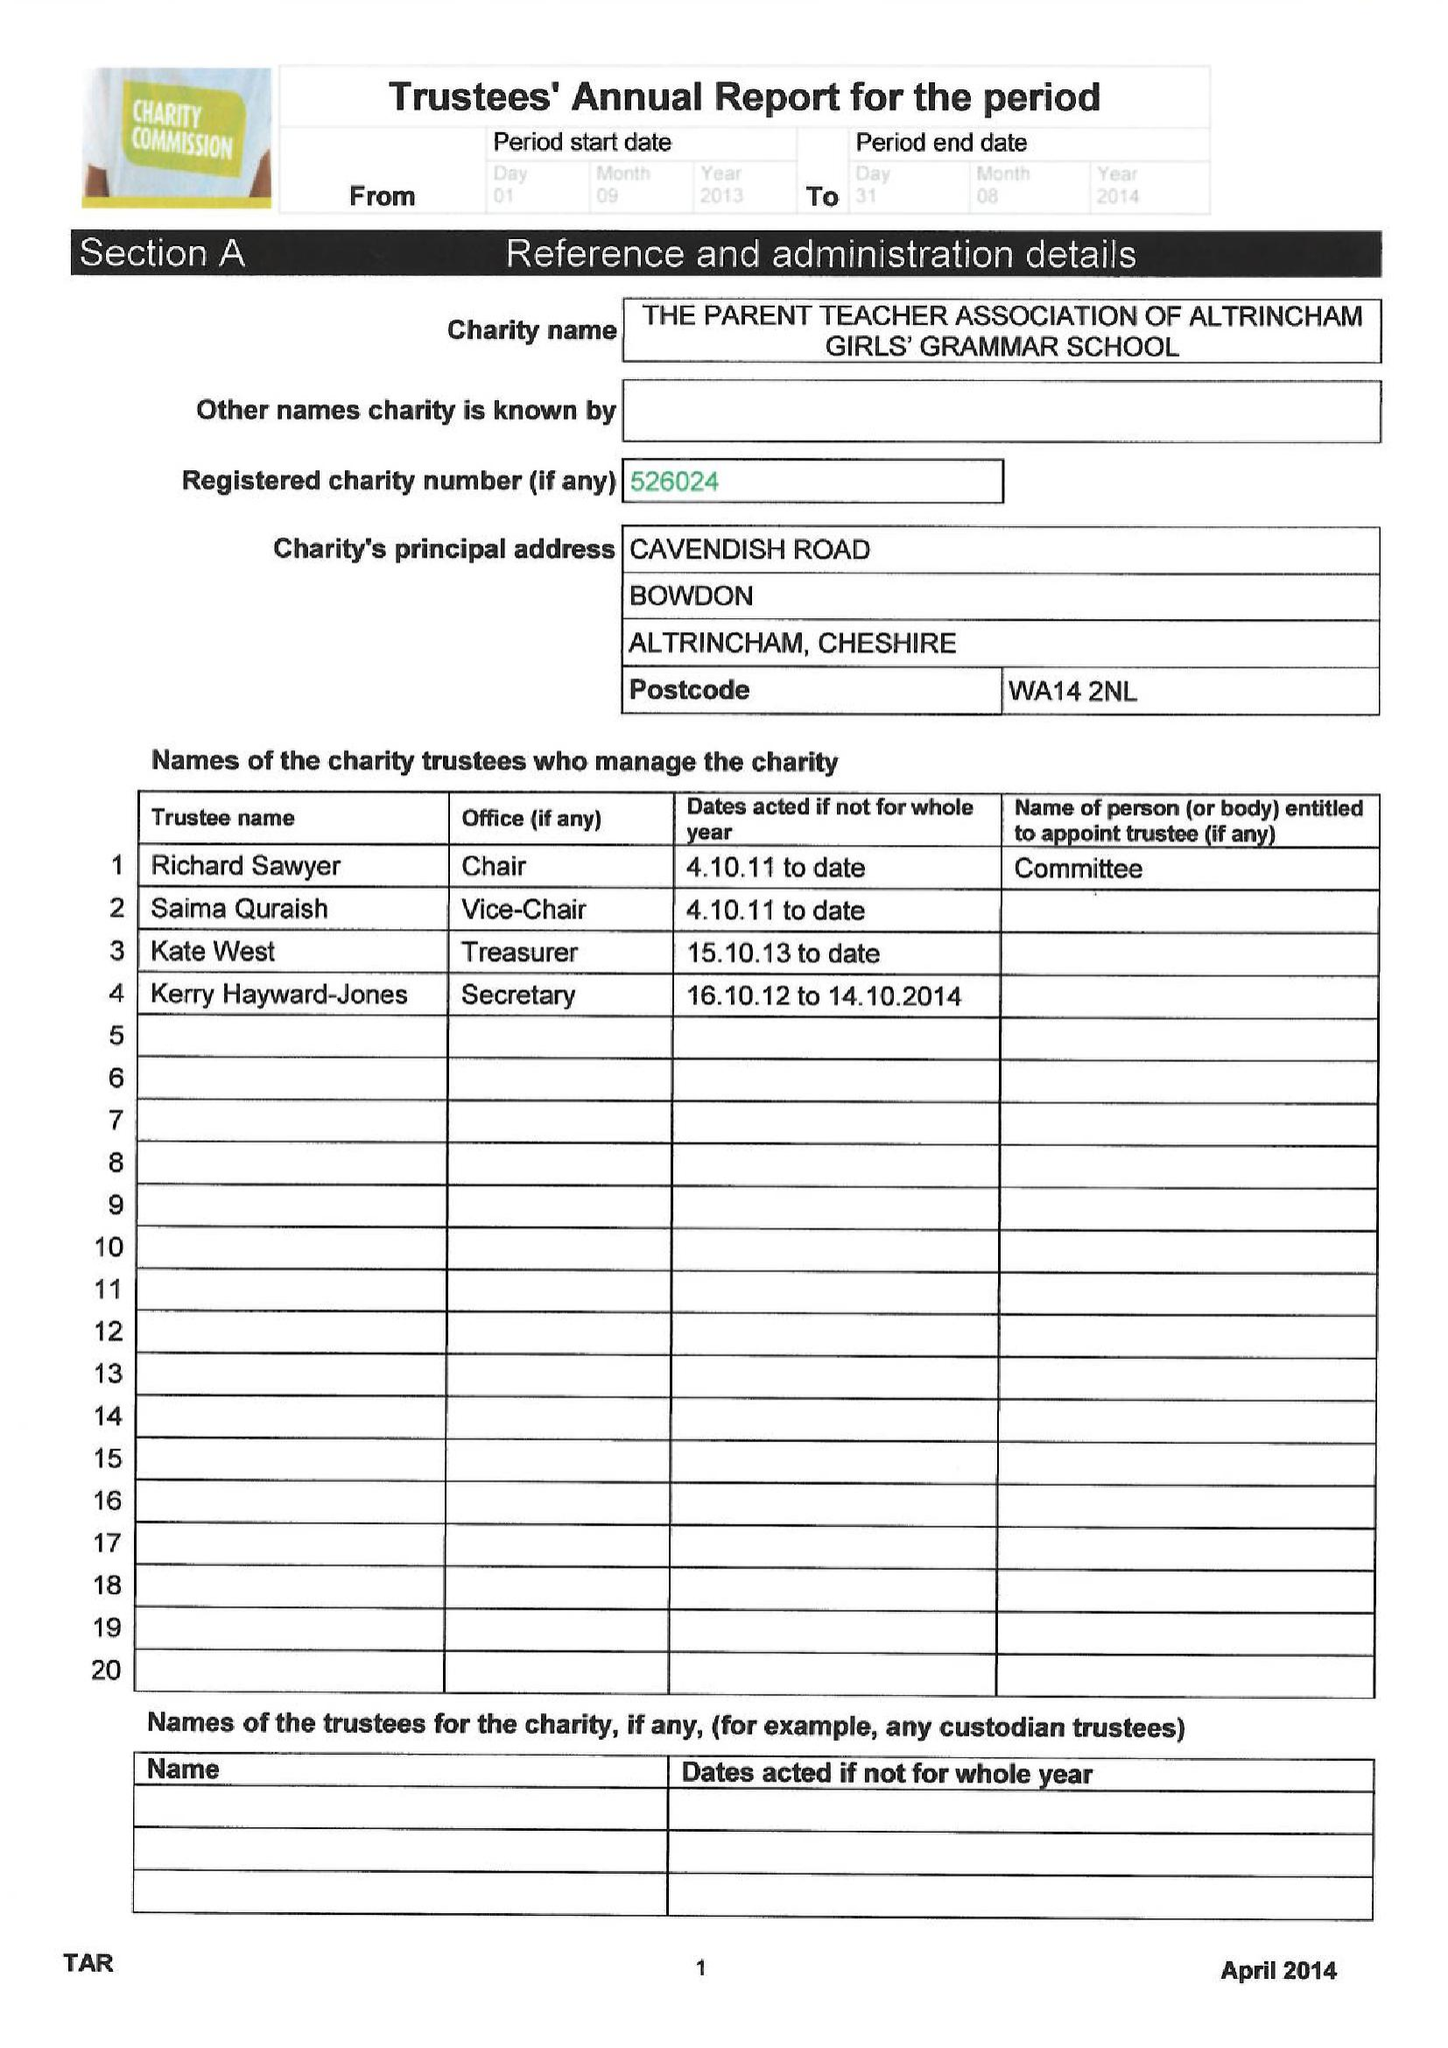What is the value for the charity_name?
Answer the question using a single word or phrase. The Parent Teacher Association Of Altrincham Grammar School For Girls 